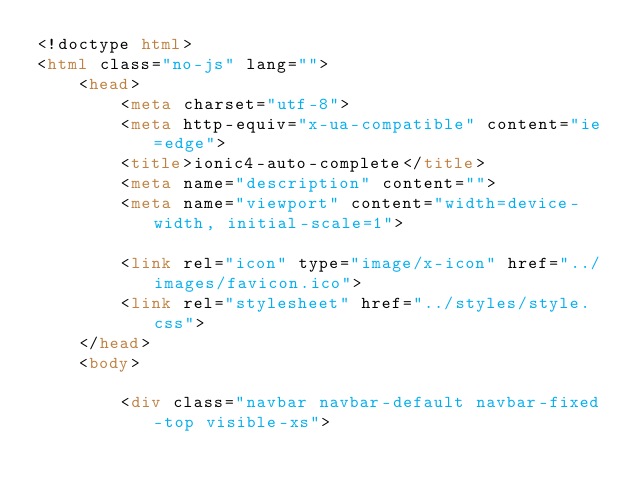Convert code to text. <code><loc_0><loc_0><loc_500><loc_500><_HTML_><!doctype html>
<html class="no-js" lang="">
    <head>
        <meta charset="utf-8">
        <meta http-equiv="x-ua-compatible" content="ie=edge">
        <title>ionic4-auto-complete</title>
        <meta name="description" content="">
        <meta name="viewport" content="width=device-width, initial-scale=1">

        <link rel="icon" type="image/x-icon" href="../images/favicon.ico">
	      <link rel="stylesheet" href="../styles/style.css">
    </head>
    <body>

        <div class="navbar navbar-default navbar-fixed-top visible-xs"></code> 